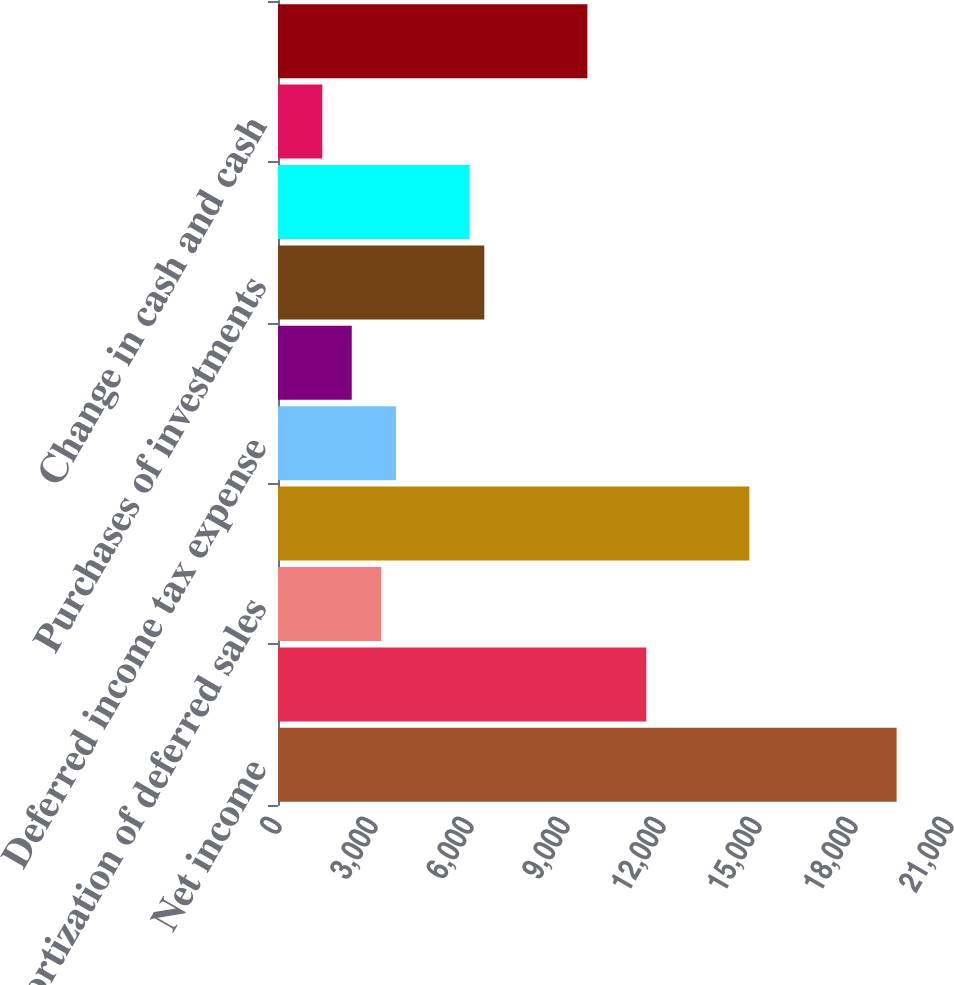<chart> <loc_0><loc_0><loc_500><loc_500><bar_chart><fcel>Net income<fcel>Depreciation and amortization<fcel>Amortization of deferred sales<fcel>Stock-based compensation<fcel>Deferred income tax expense<fcel>Net (gains) losses on<fcel>Purchases of investments<fcel>Proceeds from sales and<fcel>Change in cash and cash<fcel>Net (purchases) proceeds<nl><fcel>19332.4<fcel>11509<fcel>3225.4<fcel>14730.4<fcel>3685.6<fcel>2305<fcel>6446.8<fcel>5986.6<fcel>1384.6<fcel>9668.2<nl></chart> 